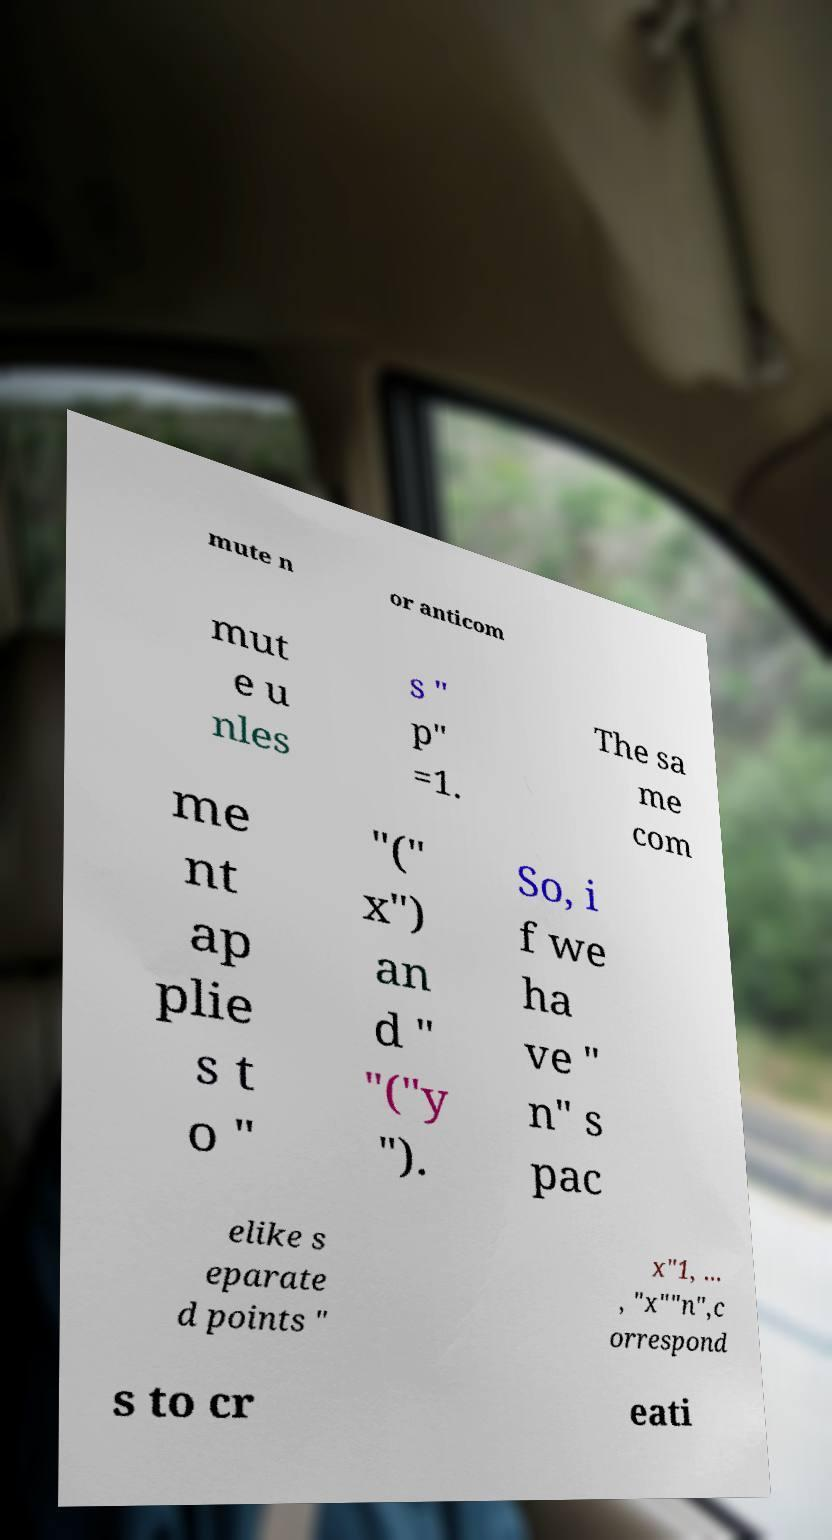Please identify and transcribe the text found in this image. mute n or anticom mut e u nles s " p" =1. The sa me com me nt ap plie s t o " "(" x") an d " "("y "). So, i f we ha ve " n" s pac elike s eparate d points " x"1, ... , "x""n",c orrespond s to cr eati 